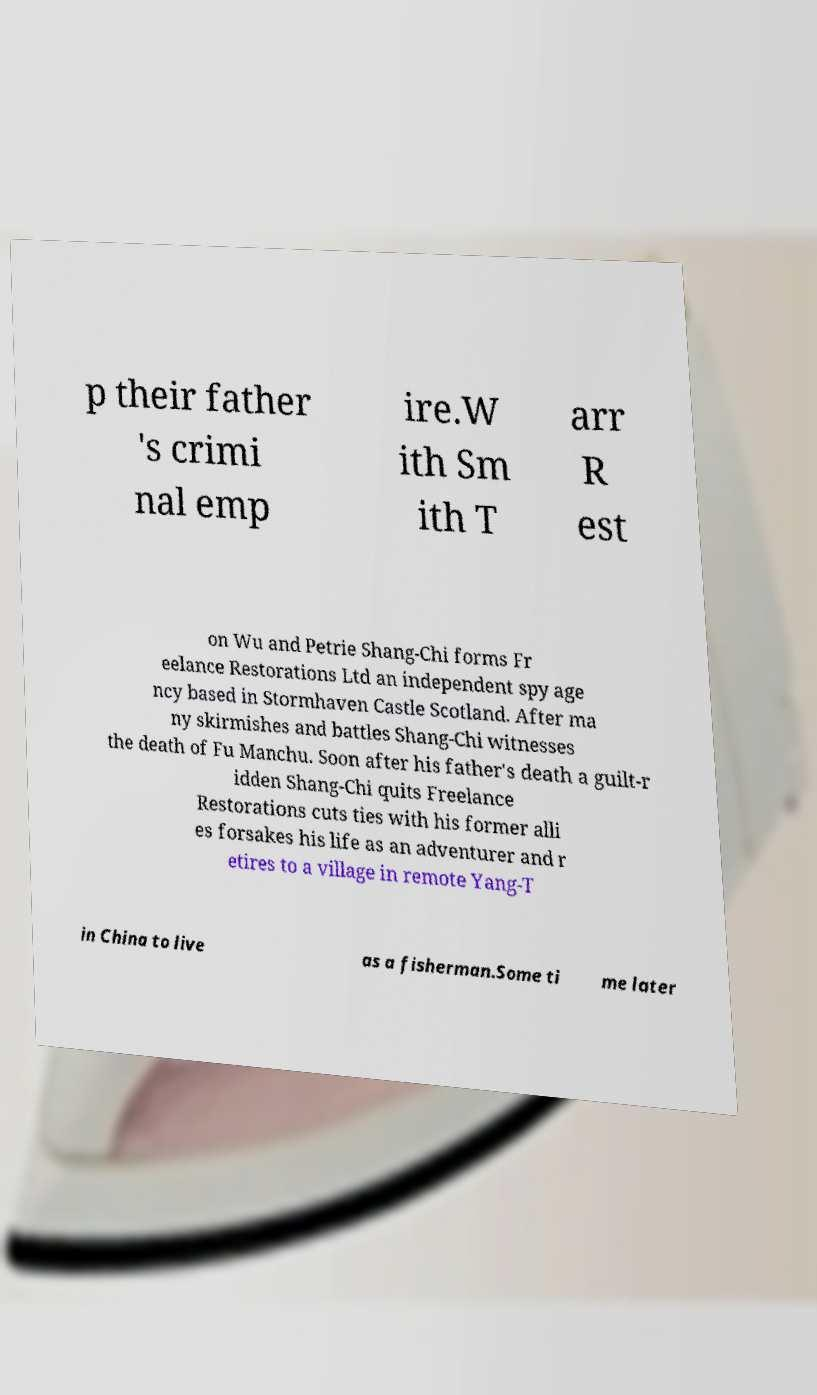There's text embedded in this image that I need extracted. Can you transcribe it verbatim? p their father 's crimi nal emp ire.W ith Sm ith T arr R est on Wu and Petrie Shang-Chi forms Fr eelance Restorations Ltd an independent spy age ncy based in Stormhaven Castle Scotland. After ma ny skirmishes and battles Shang-Chi witnesses the death of Fu Manchu. Soon after his father's death a guilt-r idden Shang-Chi quits Freelance Restorations cuts ties with his former alli es forsakes his life as an adventurer and r etires to a village in remote Yang-T in China to live as a fisherman.Some ti me later 